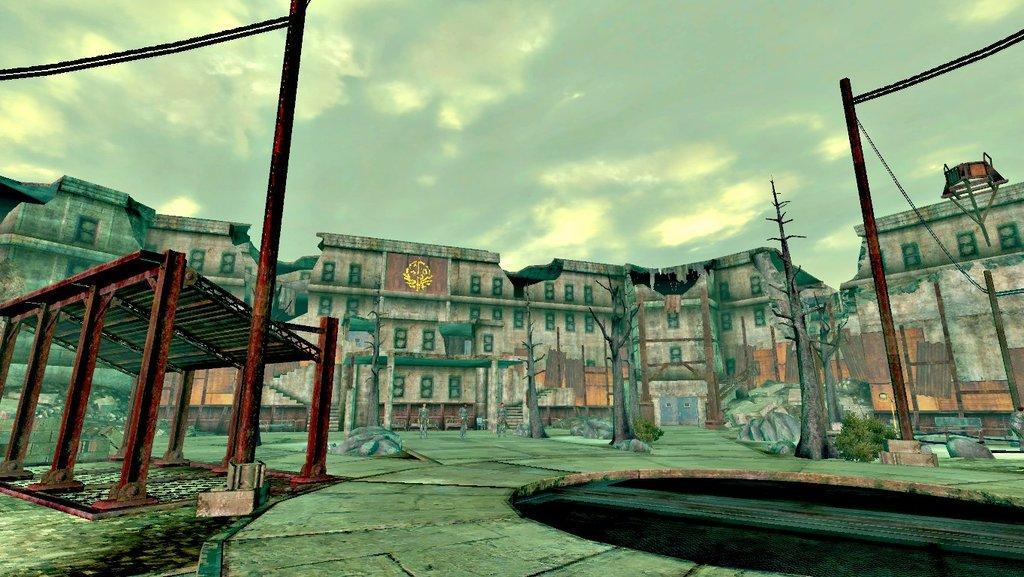How would you summarize this image in a sentence or two? This is an animated image. In this image, in the middle, we can see three persons. In the background, there are some buildings, trees, plants, poles. On top there is a sky. 